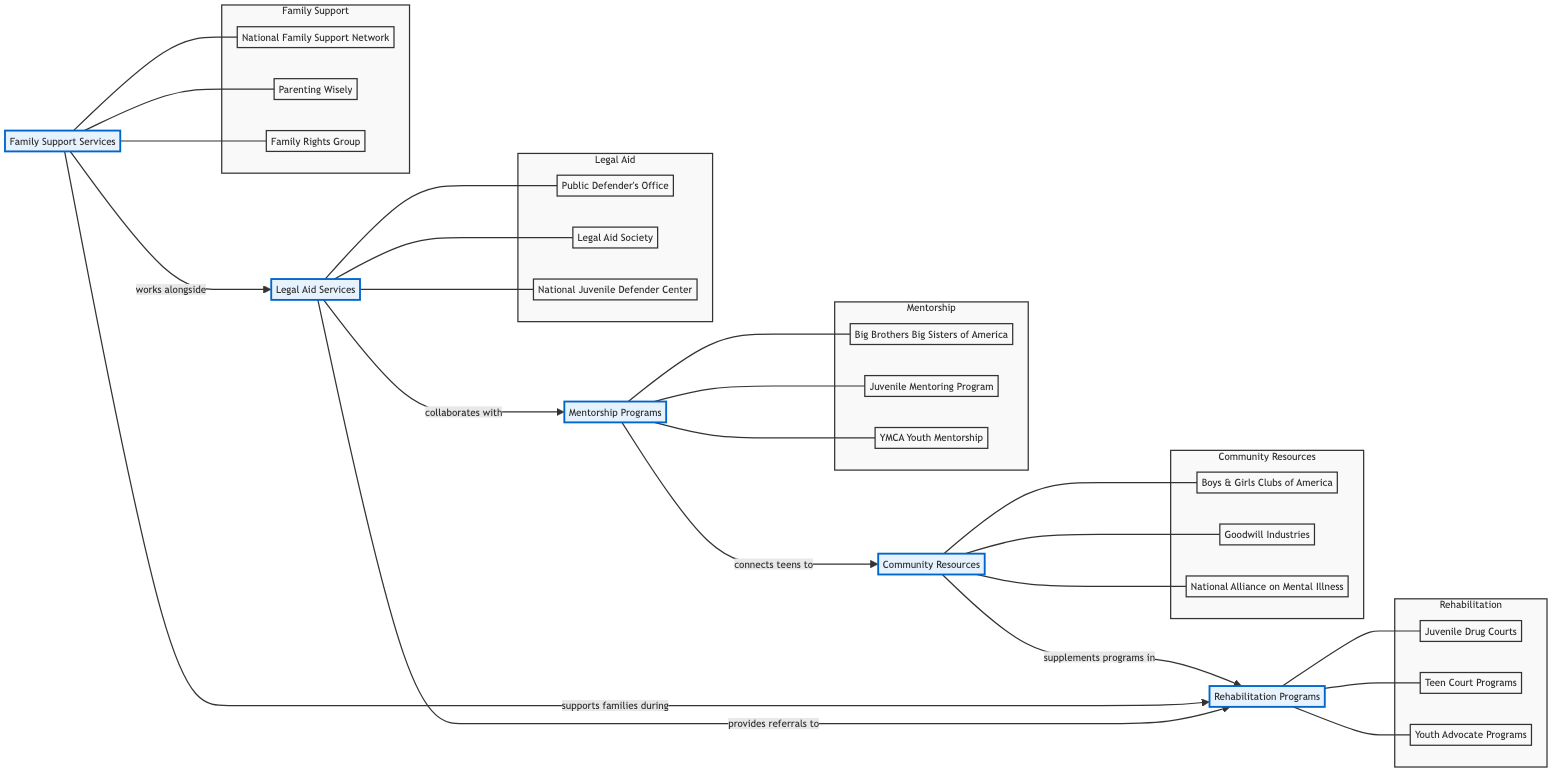What are the three types of support systems for teenagers in legal trouble represented in the diagram? The diagram includes three types of support: Legal Aid Services, Mentorship Programs, and Rehabilitation Programs. Each of these nodes is labeled accordingly and represents a distinct category of support for teenagers.
Answer: Legal Aid Services, Mentorship Programs, Rehabilitation Programs How many entities are listed under Legal Aid Services? The Legal Aid Services node includes three specific entities: Public Defender's Office, Legal Aid Society, and National Juvenile Defender Center. The diagram shows all three entities connected to the Legal Aid node.
Answer: 3 What kind of relationship exists between Legal Aid Services and Rehabilitation Programs? The diagram indicates that Legal Aid Services "provides referrals to" Rehabilitation Programs. This relationship is explicitly noted on the connecting arrow between these two nodes.
Answer: provides referrals to Which program connects teenagers to Community Resources? The Mentorship Programs node is responsible for connecting teenagers to Community Resources as indicated by the relationship described on the connecting arrow between these two entities in the diagram.
Answer: Mentorship Programs What support does Family Support Services provide during the rehabilitation process? According to the diagram, Family Support Services "supports families during" Rehabilitation Programs. This relationship is explicitly shown as an arrow connecting these two nodes.
Answer: supports families during How many total nodes are present in the diagram? The diagram includes a total of five main nodes: Legal Aid Services, Mentorship Programs, Rehabilitation Programs, Family Support Services, and Community Resources. Each node represents a different aspect of support for teenagers in legal trouble.
Answer: 5 Which two categories collaborate according to the diagram? The diagram shows that Legal Aid Services and Mentorship Programs "collaborate with" each other. This collaboration is clearly marked by the relationship arrow between the two nodes.
Answer: collaborate with What role do Community Resources play in relation to Rehabilitation Programs? Community Resources "supplement programs in" Rehabilitation Programs, according to the diagram. This means they provide additional support which enhances the effectiveness of the rehabilitation efforts.
Answer: supplements programs in Which mentorship organization is listed under Mentorship Programs in the diagram? The diagram identifies several organizations within the Mentorship Programs category; one example is "Big Brothers Big Sisters of America," which is one of the entities listed under this node.
Answer: Big Brothers Big Sisters of America 